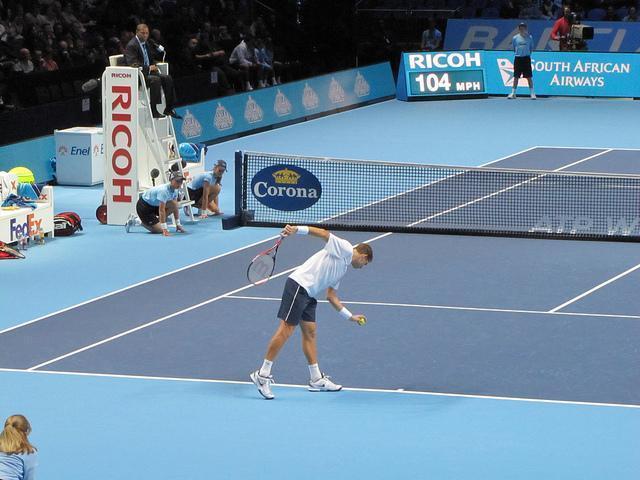How many people are there?
Give a very brief answer. 2. 